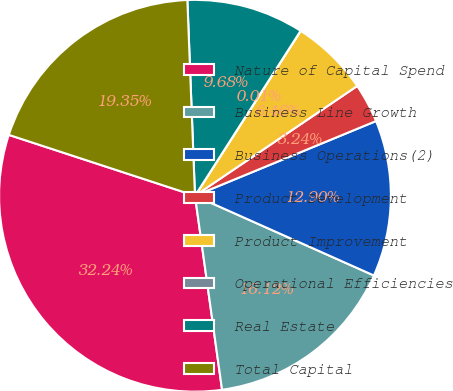<chart> <loc_0><loc_0><loc_500><loc_500><pie_chart><fcel>Nature of Capital Spend<fcel>Business Line Growth<fcel>Business Operations(2)<fcel>Product Development<fcel>Product Improvement<fcel>Operational Efficiencies<fcel>Real Estate<fcel>Total Capital<nl><fcel>32.24%<fcel>16.12%<fcel>12.9%<fcel>3.24%<fcel>6.46%<fcel>0.01%<fcel>9.68%<fcel>19.35%<nl></chart> 